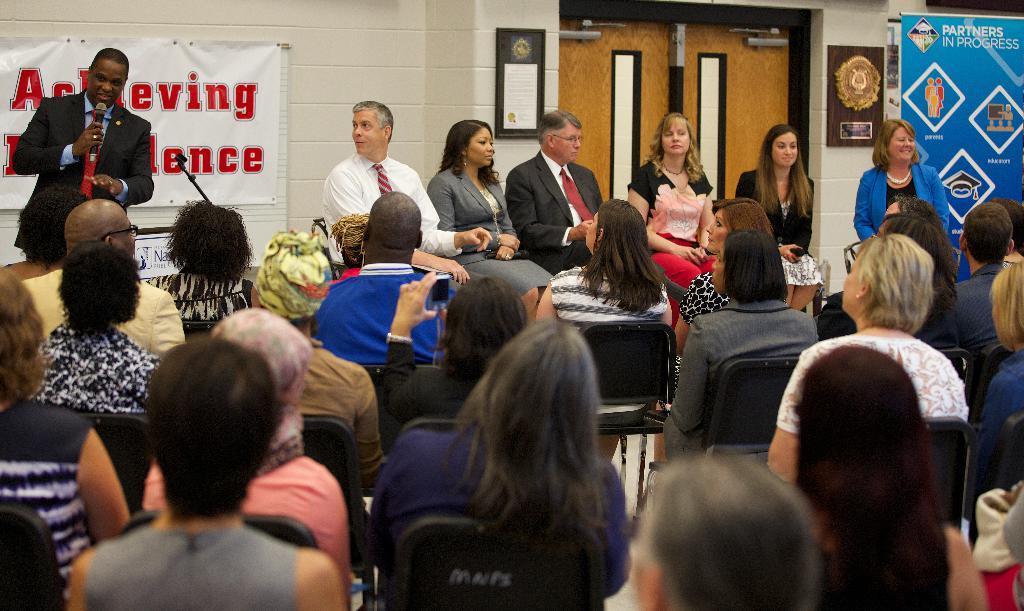Could you give a brief overview of what you see in this image? In this image in the front there are group of persons sitting. In the background there are persons sitting and standing and there is a man standing and holding a mic in his hand and speaking. In the background there are boards with some text written on it and there is a door and on the wall there are frames and the wall is white in colour. 